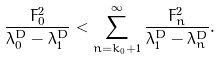Convert formula to latex. <formula><loc_0><loc_0><loc_500><loc_500>\frac { F _ { 0 } ^ { 2 } } { \lambda _ { 0 } ^ { D } - \lambda _ { 1 } ^ { D } } < \sum _ { n = k _ { 0 } + 1 } ^ { \infty } \frac { F ^ { 2 } _ { n } } { \lambda _ { 1 } ^ { D } - \lambda _ { n } ^ { D } } .</formula> 